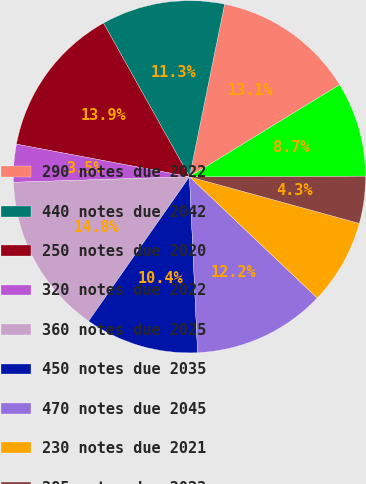Convert chart to OTSL. <chart><loc_0><loc_0><loc_500><loc_500><pie_chart><fcel>290 notes due 2022<fcel>440 notes due 2042<fcel>250 notes due 2020<fcel>320 notes due 2022<fcel>360 notes due 2025<fcel>450 notes due 2035<fcel>470 notes due 2045<fcel>230 notes due 2021<fcel>285 notes due 2023<fcel>320 notes due 2026<nl><fcel>13.05%<fcel>11.31%<fcel>13.92%<fcel>3.46%<fcel>14.79%<fcel>10.44%<fcel>12.18%<fcel>7.82%<fcel>4.33%<fcel>8.69%<nl></chart> 